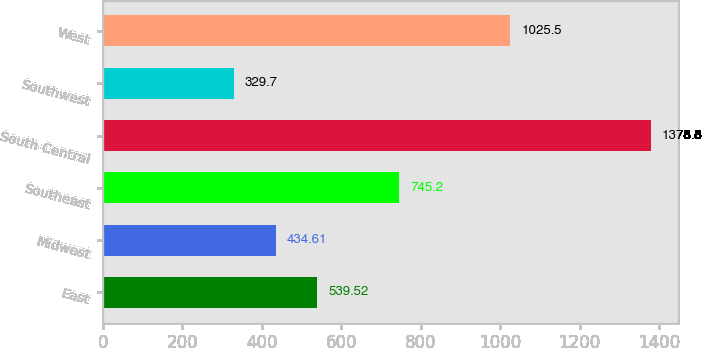Convert chart to OTSL. <chart><loc_0><loc_0><loc_500><loc_500><bar_chart><fcel>East<fcel>Midwest<fcel>Southeast<fcel>South Central<fcel>Southwest<fcel>West<nl><fcel>539.52<fcel>434.61<fcel>745.2<fcel>1378.8<fcel>329.7<fcel>1025.5<nl></chart> 